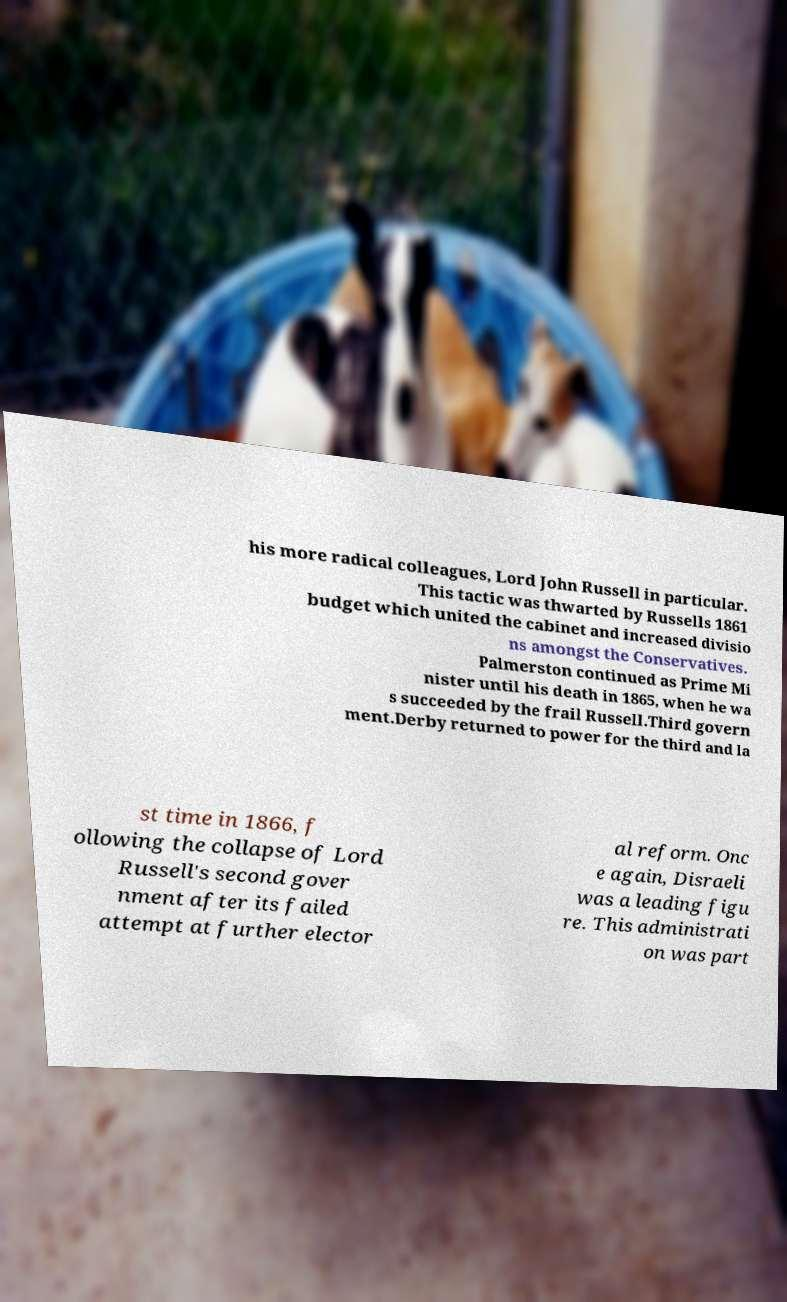I need the written content from this picture converted into text. Can you do that? his more radical colleagues, Lord John Russell in particular. This tactic was thwarted by Russells 1861 budget which united the cabinet and increased divisio ns amongst the Conservatives. Palmerston continued as Prime Mi nister until his death in 1865, when he wa s succeeded by the frail Russell.Third govern ment.Derby returned to power for the third and la st time in 1866, f ollowing the collapse of Lord Russell's second gover nment after its failed attempt at further elector al reform. Onc e again, Disraeli was a leading figu re. This administrati on was part 